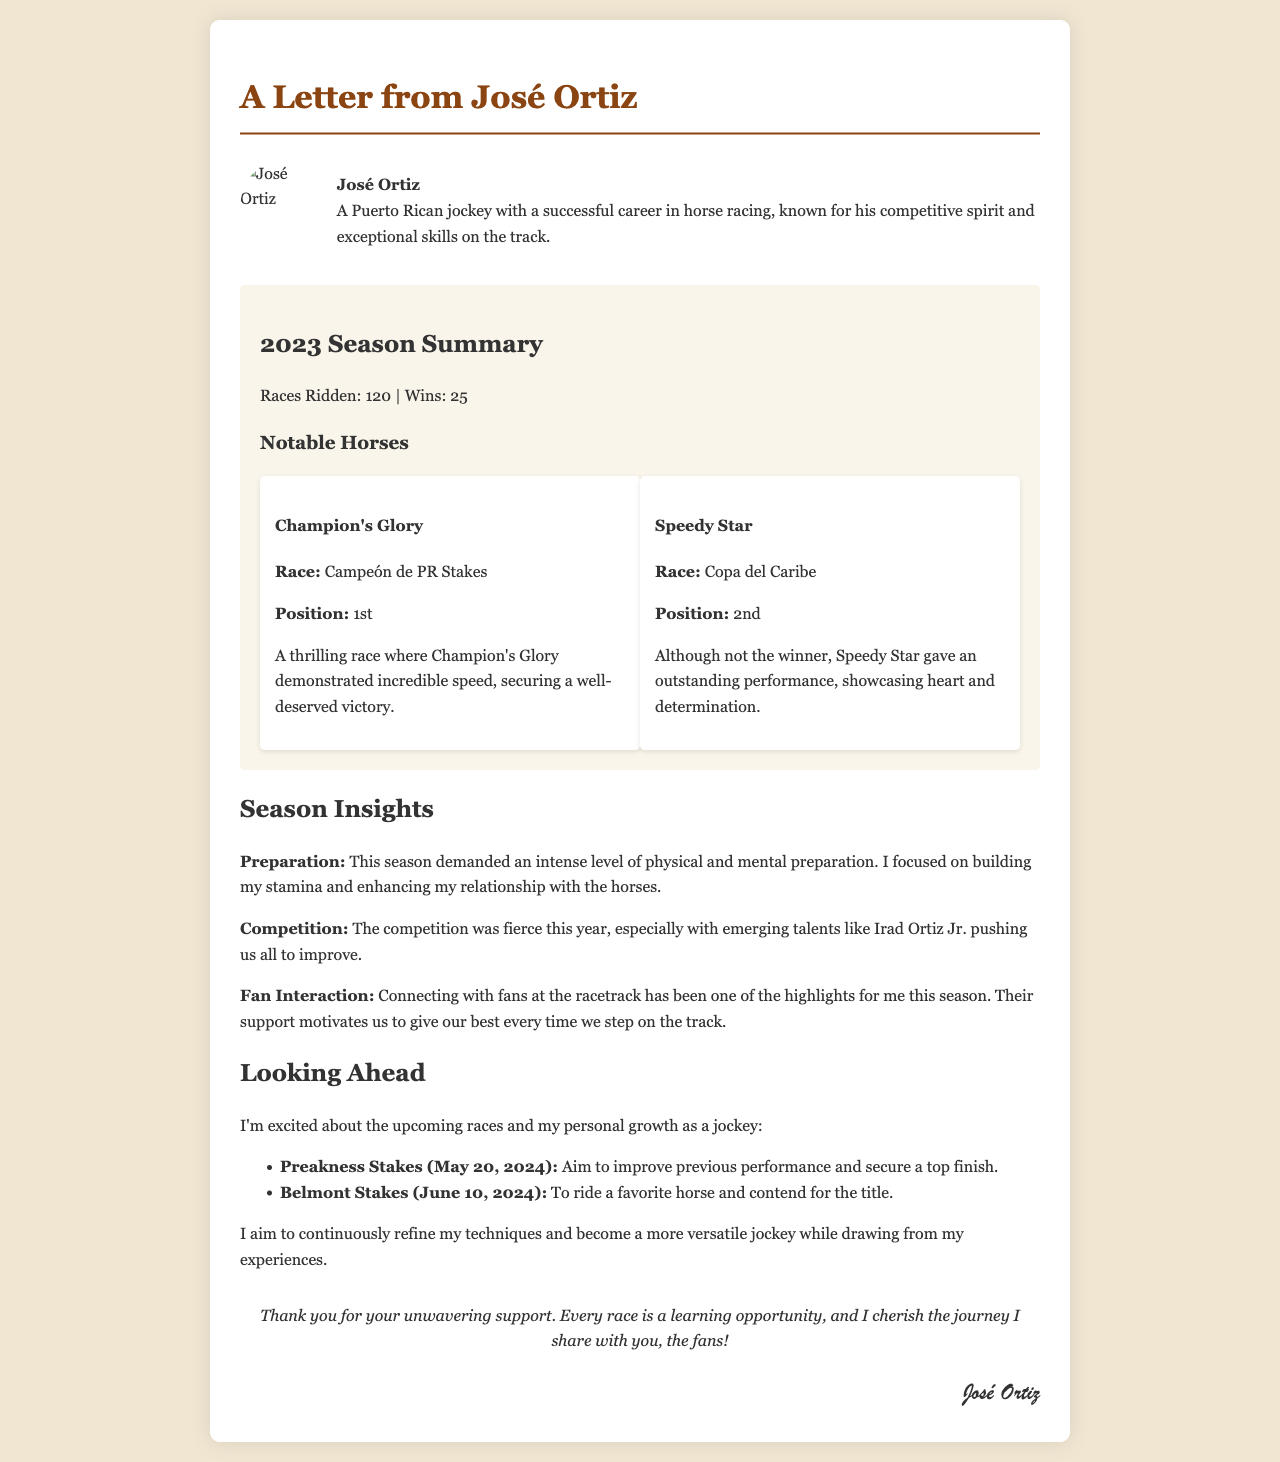What is the name of the jockey? The jockey's name is mentioned prominently at the beginning of the letter.
Answer: José Ortiz How many races did José Ortiz ride in the 2023 season? The document specifies the total number of races ridden by the jockey.
Answer: 120 What was José Ortiz's total number of wins in the 2023 season? The total wins are clearly stated in the season summary.
Answer: 25 Which horse won the Campeón de PR Stakes? The letter highlights a notable horse and its victory in a particular race.
Answer: Champion's Glory What position did Speedy Star achieve in the Copa del Caribe? The document provides specific placements for the notable horses mentioned.
Answer: 2nd What was one of José Ortiz's goals for the Preakness Stakes? The letter outlines specific goals for future races, focusing on improvement.
Answer: Improve previous performance Who was seen as a fierce competitor during the season? The text mentions a specific jockey as a competitive force in the current season.
Answer: Irad Ortiz Jr What should fans expect from José Ortiz next season? The document discusses the jockey's personal growth and improvements for future races.
Answer: Personal growth What is a highlight of José Ortiz's season? The letter emphasizes an aspect of fan interaction that Jorge appreciated throughout the season.
Answer: Connecting with fans 